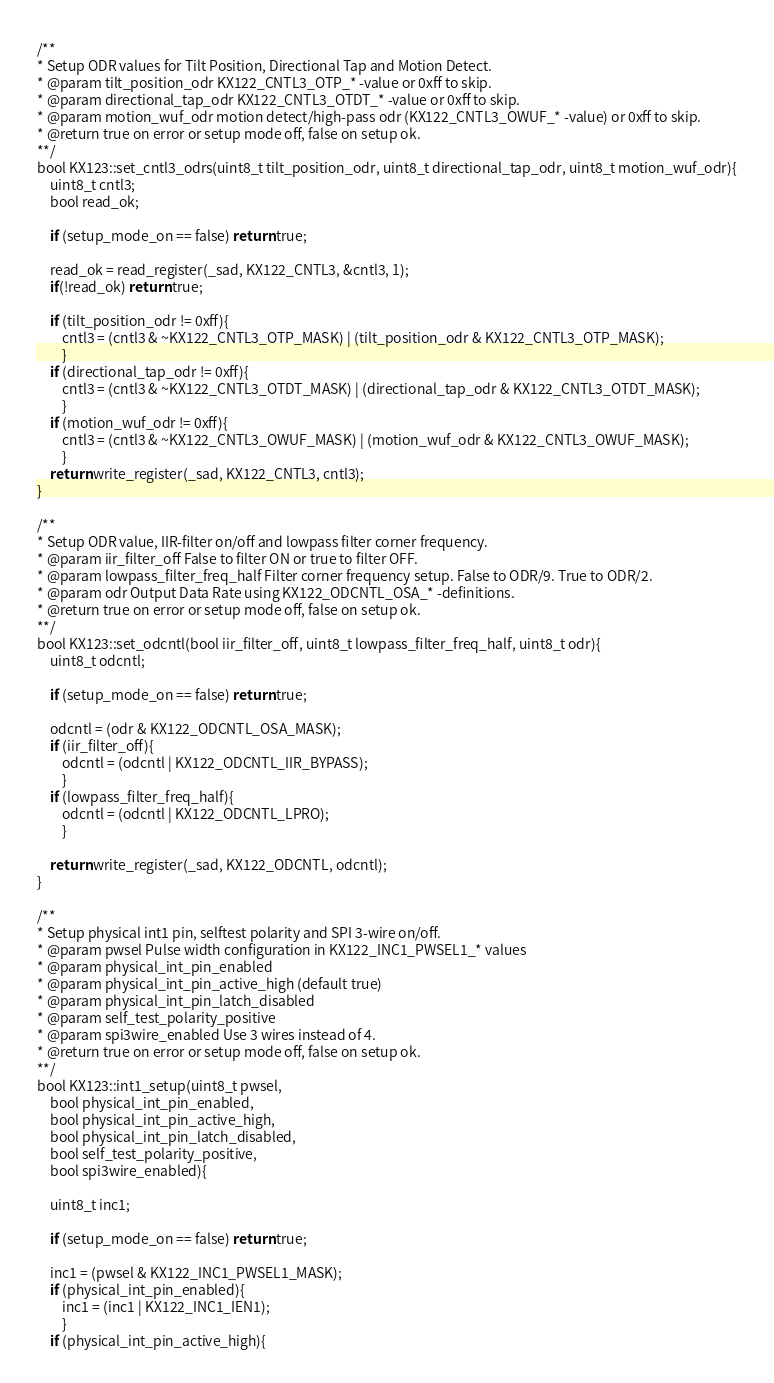<code> <loc_0><loc_0><loc_500><loc_500><_C++_>
/**
* Setup ODR values for Tilt Position, Directional Tap and Motion Detect.
* @param tilt_position_odr KX122_CNTL3_OTP_* -value or 0xff to skip.
* @param directional_tap_odr KX122_CNTL3_OTDT_* -value or 0xff to skip.
* @param motion_wuf_odr motion detect/high-pass odr (KX122_CNTL3_OWUF_* -value) or 0xff to skip.
* @return true on error or setup mode off, false on setup ok.
**/
bool KX123::set_cntl3_odrs(uint8_t tilt_position_odr, uint8_t directional_tap_odr, uint8_t motion_wuf_odr){
    uint8_t cntl3;
    bool read_ok;

    if (setup_mode_on == false) return true;

    read_ok = read_register(_sad, KX122_CNTL3, &cntl3, 1);
    if(!read_ok) return true;
    
    if (tilt_position_odr != 0xff){
        cntl3 = (cntl3 & ~KX122_CNTL3_OTP_MASK) | (tilt_position_odr & KX122_CNTL3_OTP_MASK);
        }
    if (directional_tap_odr != 0xff){
        cntl3 = (cntl3 & ~KX122_CNTL3_OTDT_MASK) | (directional_tap_odr & KX122_CNTL3_OTDT_MASK);
        }
    if (motion_wuf_odr != 0xff){
        cntl3 = (cntl3 & ~KX122_CNTL3_OWUF_MASK) | (motion_wuf_odr & KX122_CNTL3_OWUF_MASK);
        }
    return write_register(_sad, KX122_CNTL3, cntl3);
}

/**
* Setup ODR value, IIR-filter on/off and lowpass filter corner frequency.
* @param iir_filter_off False to filter ON or true to filter OFF.
* @param lowpass_filter_freq_half Filter corner frequency setup. False to ODR/9. True to ODR/2.
* @param odr Output Data Rate using KX122_ODCNTL_OSA_* -definitions.
* @return true on error or setup mode off, false on setup ok.
**/
bool KX123::set_odcntl(bool iir_filter_off, uint8_t lowpass_filter_freq_half, uint8_t odr){
    uint8_t odcntl;

    if (setup_mode_on == false) return true;

    odcntl = (odr & KX122_ODCNTL_OSA_MASK);
    if (iir_filter_off){
        odcntl = (odcntl | KX122_ODCNTL_IIR_BYPASS);
        }
    if (lowpass_filter_freq_half){
        odcntl = (odcntl | KX122_ODCNTL_LPRO);
        }

    return write_register(_sad, KX122_ODCNTL, odcntl);
}

/**
* Setup physical int1 pin, selftest polarity and SPI 3-wire on/off.
* @param pwsel Pulse width configuration in KX122_INC1_PWSEL1_* values
* @param physical_int_pin_enabled
* @param physical_int_pin_active_high (default true)
* @param physical_int_pin_latch_disabled
* @param self_test_polarity_positive
* @param spi3wire_enabled Use 3 wires instead of 4.
* @return true on error or setup mode off, false on setup ok.
**/
bool KX123::int1_setup(uint8_t pwsel,
    bool physical_int_pin_enabled,
    bool physical_int_pin_active_high,
    bool physical_int_pin_latch_disabled,
    bool self_test_polarity_positive,
    bool spi3wire_enabled){

    uint8_t inc1;

    if (setup_mode_on == false) return true;

    inc1 = (pwsel & KX122_INC1_PWSEL1_MASK);
    if (physical_int_pin_enabled){
        inc1 = (inc1 | KX122_INC1_IEN1);
        }
    if (physical_int_pin_active_high){</code> 